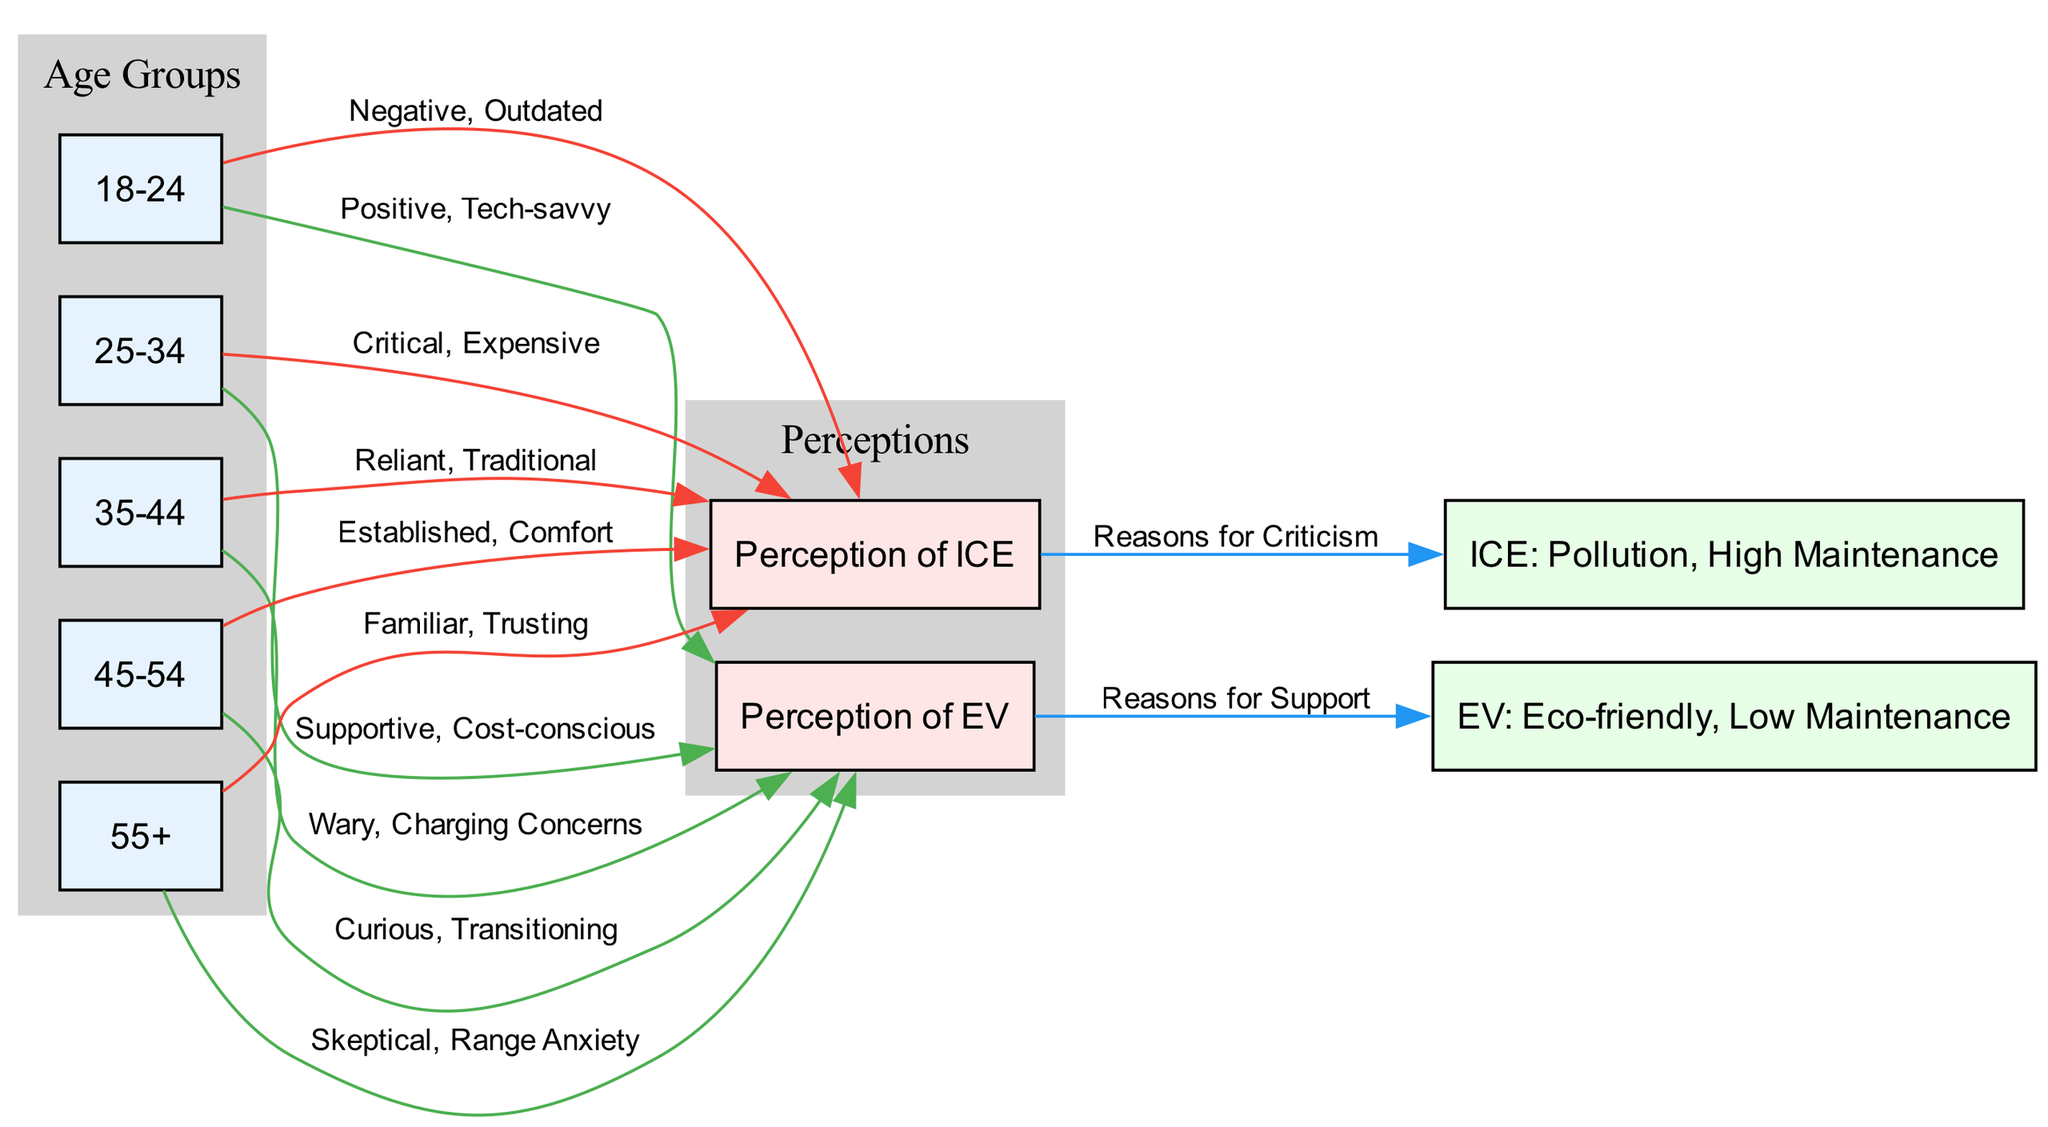What age group has a positive perception of electric vehicles? According to the diagram, the age group "18-24" has a positive perception of electric vehicles, as indicated by the edge connecting this node to "Perception of EV" with the label "Positive, Tech-savvy."
Answer: 18-24 How many age groups are represented in the diagram? The diagram lists five different age groups, which are "18-24," "25-34," "35-44," "45-54," and "55+." Counting these gives a total of five age groups.
Answer: 5 What is the perception of internal combustion engine vehicles from the age group 35-44? The perception from the age group "35-44" towards internal combustion engine vehicles is described as "Reliant, Traditional," as indicated by the edge to "Perception of ICE."
Answer: Reliant, Traditional Which age group is skeptical about electric vehicles? The age group "55+" is labeled as "Skeptical, Range Anxiety," indicating their skepticism towards electric vehicles, as shown by the edge to "Perception of EV."
Answer: 55+ What are the reasons for support of electric vehicles? The reasons for support are indicated by the connection from "Perception of EV" to "EV: Eco-friendly, Low Maintenance," which shows that these are the benefits viewed favorably.
Answer: Reasons for Support Which age group has critical views towards internal combustion engine vehicles? The age group "25-34" is described as "Critical, Expensive" towards internal combustion engine vehicles, evidenced by the edge to "Perception of ICE."
Answer: 25-34 What is a common concern about electric vehicles from the age group 35-44? The edge from "35-44" to "Perception of EV" states that they are "Wary, Charging Concerns," indicating this group has concerns about charging.
Answer: Charging Concerns What color is used to represent connections that reflect positive perceptions of EV? The color green (#4CAF50) is used for edges that indicate positive perceptions of electric vehicles. This is evident in the connections from age groups to "Perception of EV."
Answer: Green How does the perception of ICE from age group 45-54 differ from that of age group 18-24? The age group "45-54" views ICE as "Established, Comfort," while "18-24" sees it as "Negative, Outdated." The differences indicate a generational contrast in views towards ICE.
Answer: Established, Comfort vs. Negative, Outdated 